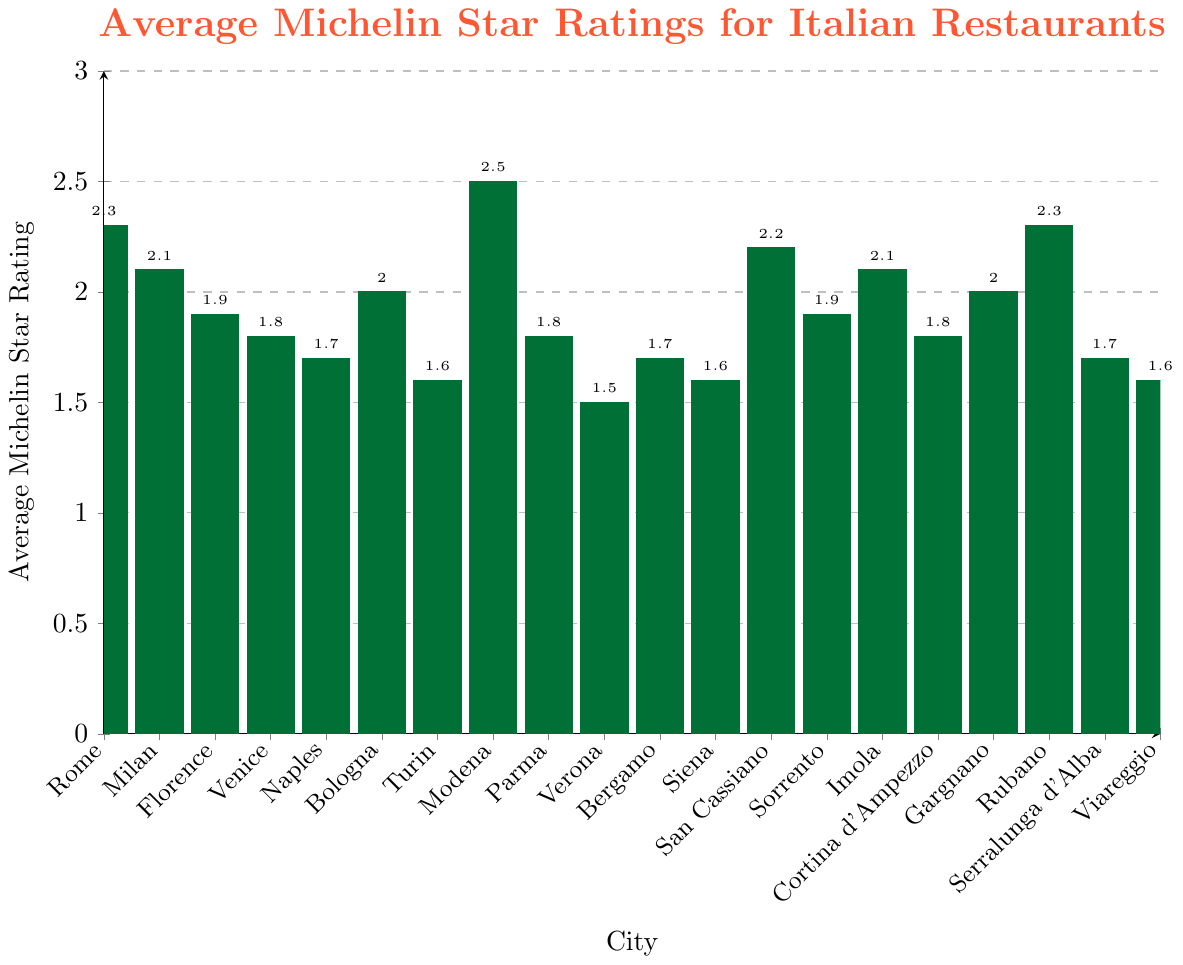Which city has the highest average Michelin star rating? By visually inspecting the height of the bars, Modena has the highest average Michelin star rating as it has the tallest bar.
Answer: Modena Which cities have an average Michelin star rating of at least 2.0 but less than 2.5? By visually observing the bars, cities with ratings in the 2.0 to 2.5 range are Rome, Milan, Bologna, San Cassiano, Imola, and Rubano.
Answer: Rome, Milan, Bologna, San Cassiano, Imola, Rubano What is the difference in average Michelin star ratings between Rome and Verona? The average rating for Rome is 2.3 and for Verona it is 1.5. The difference is 2.3 - 1.5.
Answer: 0.8 Which city has a lower average Michelin star rating, Venice or Florence? By comparing the height of the bars, Venice has a lower average rating (1.8) compared to Florence (1.9).
Answer: Venice What are the average Michelin star ratings for the cities with the three lowest ratings? The cities with the lowest bars are Verona, Viareggio, and Turin, each having average ratings of 1.5, 1.6, and 1.6 respectively.
Answer: 1.5, 1.6, 1.6 What is the average of the average Michelin star ratings for Naples, Modena, and Sorrento? The ratings are 1.7 for Naples, 2.5 for Modena, and 1.9 for Sorrento. The average is (1.7 + 2.5 + 1.9)/3.
Answer: 2.03 Is the average Michelin star rating for Parma higher than the rating for Cortina d'Ampezzo? By comparing the bars, Parma and Cortina d'Ampezzo have the same rating of 1.8.
Answer: No Which two cities have an equal average Michelin star rating and what is that rating? By looking at the bars, the cities of Siena and Viareggio both have a rating of 1.6.
Answer: Siena, Viareggio; 1.6 What is the sum of the average Michelin star ratings for Gargnano and Bologna? The rating for Gargnano is 2.0 and for Bologna is 2.0. The sum is 2.0 + 2.0.
Answer: 4.0 